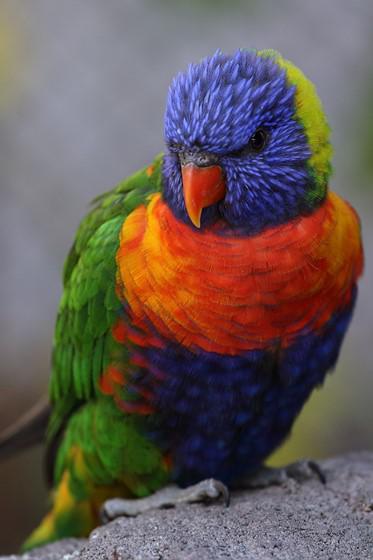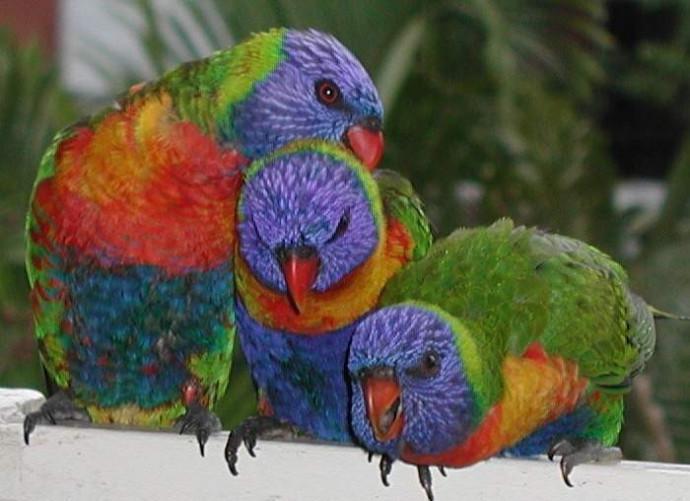The first image is the image on the left, the second image is the image on the right. Given the left and right images, does the statement "A total of six birds are shown, and at least some are perching on light-colored, smooth wood." hold true? Answer yes or no. No. The first image is the image on the left, the second image is the image on the right. Given the left and right images, does the statement "There is exactly three parrots in the right image." hold true? Answer yes or no. Yes. 